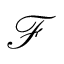Convert formula to latex. <formula><loc_0><loc_0><loc_500><loc_500>\mathcal { F }</formula> 